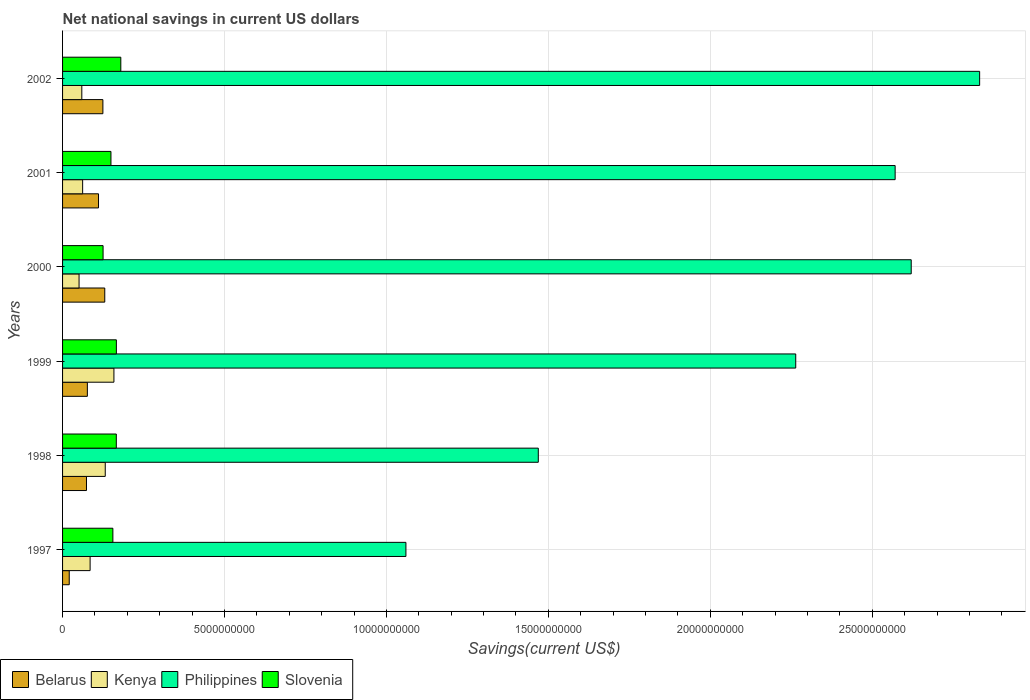Are the number of bars per tick equal to the number of legend labels?
Provide a succinct answer. Yes. How many bars are there on the 4th tick from the top?
Provide a succinct answer. 4. How many bars are there on the 5th tick from the bottom?
Keep it short and to the point. 4. What is the label of the 2nd group of bars from the top?
Your answer should be compact. 2001. What is the net national savings in Kenya in 1997?
Your answer should be compact. 8.50e+08. Across all years, what is the maximum net national savings in Belarus?
Provide a short and direct response. 1.30e+09. Across all years, what is the minimum net national savings in Belarus?
Your answer should be compact. 2.06e+08. In which year was the net national savings in Philippines minimum?
Your answer should be compact. 1997. What is the total net national savings in Philippines in the graph?
Give a very brief answer. 1.28e+11. What is the difference between the net national savings in Slovenia in 1999 and that in 2002?
Provide a succinct answer. -1.37e+08. What is the difference between the net national savings in Kenya in 1998 and the net national savings in Philippines in 2001?
Offer a terse response. -2.44e+1. What is the average net national savings in Slovenia per year?
Offer a terse response. 1.57e+09. In the year 1998, what is the difference between the net national savings in Slovenia and net national savings in Kenya?
Ensure brevity in your answer.  3.42e+08. What is the ratio of the net national savings in Kenya in 1997 to that in 2000?
Keep it short and to the point. 1.67. Is the net national savings in Kenya in 1997 less than that in 2000?
Offer a terse response. No. Is the difference between the net national savings in Slovenia in 1998 and 2000 greater than the difference between the net national savings in Kenya in 1998 and 2000?
Provide a succinct answer. No. What is the difference between the highest and the second highest net national savings in Slovenia?
Your answer should be compact. 1.37e+08. What is the difference between the highest and the lowest net national savings in Philippines?
Your answer should be compact. 1.77e+1. What does the 1st bar from the top in 1998 represents?
Keep it short and to the point. Slovenia. What does the 2nd bar from the bottom in 2002 represents?
Make the answer very short. Kenya. Is it the case that in every year, the sum of the net national savings in Philippines and net national savings in Kenya is greater than the net national savings in Belarus?
Ensure brevity in your answer.  Yes. Are all the bars in the graph horizontal?
Your answer should be compact. Yes. Are the values on the major ticks of X-axis written in scientific E-notation?
Your answer should be very brief. No. Does the graph contain any zero values?
Offer a very short reply. No. Does the graph contain grids?
Provide a short and direct response. Yes. What is the title of the graph?
Ensure brevity in your answer.  Net national savings in current US dollars. What is the label or title of the X-axis?
Make the answer very short. Savings(current US$). What is the Savings(current US$) in Belarus in 1997?
Offer a terse response. 2.06e+08. What is the Savings(current US$) in Kenya in 1997?
Offer a very short reply. 8.50e+08. What is the Savings(current US$) in Philippines in 1997?
Give a very brief answer. 1.06e+1. What is the Savings(current US$) in Slovenia in 1997?
Make the answer very short. 1.55e+09. What is the Savings(current US$) in Belarus in 1998?
Keep it short and to the point. 7.38e+08. What is the Savings(current US$) of Kenya in 1998?
Provide a succinct answer. 1.32e+09. What is the Savings(current US$) in Philippines in 1998?
Your response must be concise. 1.47e+1. What is the Savings(current US$) in Slovenia in 1998?
Offer a very short reply. 1.66e+09. What is the Savings(current US$) of Belarus in 1999?
Ensure brevity in your answer.  7.66e+08. What is the Savings(current US$) in Kenya in 1999?
Offer a terse response. 1.59e+09. What is the Savings(current US$) of Philippines in 1999?
Your answer should be compact. 2.26e+1. What is the Savings(current US$) in Slovenia in 1999?
Your response must be concise. 1.66e+09. What is the Savings(current US$) in Belarus in 2000?
Provide a succinct answer. 1.30e+09. What is the Savings(current US$) in Kenya in 2000?
Ensure brevity in your answer.  5.09e+08. What is the Savings(current US$) of Philippines in 2000?
Your response must be concise. 2.62e+1. What is the Savings(current US$) of Slovenia in 2000?
Ensure brevity in your answer.  1.25e+09. What is the Savings(current US$) in Belarus in 2001?
Ensure brevity in your answer.  1.11e+09. What is the Savings(current US$) in Kenya in 2001?
Offer a very short reply. 6.20e+08. What is the Savings(current US$) of Philippines in 2001?
Your response must be concise. 2.57e+1. What is the Savings(current US$) in Slovenia in 2001?
Make the answer very short. 1.49e+09. What is the Savings(current US$) of Belarus in 2002?
Provide a short and direct response. 1.25e+09. What is the Savings(current US$) in Kenya in 2002?
Offer a terse response. 5.94e+08. What is the Savings(current US$) in Philippines in 2002?
Give a very brief answer. 2.83e+1. What is the Savings(current US$) in Slovenia in 2002?
Provide a succinct answer. 1.80e+09. Across all years, what is the maximum Savings(current US$) in Belarus?
Make the answer very short. 1.30e+09. Across all years, what is the maximum Savings(current US$) of Kenya?
Your answer should be very brief. 1.59e+09. Across all years, what is the maximum Savings(current US$) of Philippines?
Ensure brevity in your answer.  2.83e+1. Across all years, what is the maximum Savings(current US$) of Slovenia?
Your response must be concise. 1.80e+09. Across all years, what is the minimum Savings(current US$) of Belarus?
Your response must be concise. 2.06e+08. Across all years, what is the minimum Savings(current US$) in Kenya?
Give a very brief answer. 5.09e+08. Across all years, what is the minimum Savings(current US$) in Philippines?
Ensure brevity in your answer.  1.06e+1. Across all years, what is the minimum Savings(current US$) of Slovenia?
Make the answer very short. 1.25e+09. What is the total Savings(current US$) in Belarus in the graph?
Offer a terse response. 5.37e+09. What is the total Savings(current US$) of Kenya in the graph?
Make the answer very short. 5.48e+09. What is the total Savings(current US$) of Philippines in the graph?
Offer a very short reply. 1.28e+11. What is the total Savings(current US$) of Slovenia in the graph?
Keep it short and to the point. 9.42e+09. What is the difference between the Savings(current US$) in Belarus in 1997 and that in 1998?
Provide a succinct answer. -5.33e+08. What is the difference between the Savings(current US$) in Kenya in 1997 and that in 1998?
Keep it short and to the point. -4.67e+08. What is the difference between the Savings(current US$) in Philippines in 1997 and that in 1998?
Your answer should be compact. -4.09e+09. What is the difference between the Savings(current US$) of Slovenia in 1997 and that in 1998?
Your response must be concise. -1.06e+08. What is the difference between the Savings(current US$) of Belarus in 1997 and that in 1999?
Your answer should be very brief. -5.60e+08. What is the difference between the Savings(current US$) in Kenya in 1997 and that in 1999?
Keep it short and to the point. -7.35e+08. What is the difference between the Savings(current US$) in Philippines in 1997 and that in 1999?
Give a very brief answer. -1.20e+1. What is the difference between the Savings(current US$) of Slovenia in 1997 and that in 1999?
Give a very brief answer. -1.08e+08. What is the difference between the Savings(current US$) in Belarus in 1997 and that in 2000?
Give a very brief answer. -1.10e+09. What is the difference between the Savings(current US$) of Kenya in 1997 and that in 2000?
Give a very brief answer. 3.41e+08. What is the difference between the Savings(current US$) in Philippines in 1997 and that in 2000?
Offer a very short reply. -1.56e+1. What is the difference between the Savings(current US$) of Slovenia in 1997 and that in 2000?
Give a very brief answer. 3.03e+08. What is the difference between the Savings(current US$) in Belarus in 1997 and that in 2001?
Your answer should be compact. -9.04e+08. What is the difference between the Savings(current US$) in Kenya in 1997 and that in 2001?
Provide a succinct answer. 2.31e+08. What is the difference between the Savings(current US$) of Philippines in 1997 and that in 2001?
Your answer should be very brief. -1.51e+1. What is the difference between the Savings(current US$) in Slovenia in 1997 and that in 2001?
Make the answer very short. 5.96e+07. What is the difference between the Savings(current US$) of Belarus in 1997 and that in 2002?
Your answer should be compact. -1.04e+09. What is the difference between the Savings(current US$) in Kenya in 1997 and that in 2002?
Keep it short and to the point. 2.56e+08. What is the difference between the Savings(current US$) in Philippines in 1997 and that in 2002?
Give a very brief answer. -1.77e+1. What is the difference between the Savings(current US$) in Slovenia in 1997 and that in 2002?
Make the answer very short. -2.45e+08. What is the difference between the Savings(current US$) in Belarus in 1998 and that in 1999?
Provide a short and direct response. -2.71e+07. What is the difference between the Savings(current US$) in Kenya in 1998 and that in 1999?
Offer a very short reply. -2.68e+08. What is the difference between the Savings(current US$) in Philippines in 1998 and that in 1999?
Make the answer very short. -7.95e+09. What is the difference between the Savings(current US$) of Slovenia in 1998 and that in 1999?
Provide a succinct answer. -2.00e+06. What is the difference between the Savings(current US$) of Belarus in 1998 and that in 2000?
Provide a succinct answer. -5.65e+08. What is the difference between the Savings(current US$) of Kenya in 1998 and that in 2000?
Offer a terse response. 8.08e+08. What is the difference between the Savings(current US$) of Philippines in 1998 and that in 2000?
Keep it short and to the point. -1.15e+1. What is the difference between the Savings(current US$) of Slovenia in 1998 and that in 2000?
Offer a terse response. 4.09e+08. What is the difference between the Savings(current US$) in Belarus in 1998 and that in 2001?
Your answer should be compact. -3.72e+08. What is the difference between the Savings(current US$) in Kenya in 1998 and that in 2001?
Ensure brevity in your answer.  6.98e+08. What is the difference between the Savings(current US$) of Philippines in 1998 and that in 2001?
Keep it short and to the point. -1.10e+1. What is the difference between the Savings(current US$) in Slovenia in 1998 and that in 2001?
Offer a very short reply. 1.66e+08. What is the difference between the Savings(current US$) in Belarus in 1998 and that in 2002?
Provide a succinct answer. -5.07e+08. What is the difference between the Savings(current US$) in Kenya in 1998 and that in 2002?
Your answer should be compact. 7.23e+08. What is the difference between the Savings(current US$) of Philippines in 1998 and that in 2002?
Give a very brief answer. -1.36e+1. What is the difference between the Savings(current US$) of Slovenia in 1998 and that in 2002?
Provide a succinct answer. -1.39e+08. What is the difference between the Savings(current US$) of Belarus in 1999 and that in 2000?
Your answer should be compact. -5.37e+08. What is the difference between the Savings(current US$) in Kenya in 1999 and that in 2000?
Provide a succinct answer. 1.08e+09. What is the difference between the Savings(current US$) of Philippines in 1999 and that in 2000?
Your answer should be compact. -3.57e+09. What is the difference between the Savings(current US$) in Slovenia in 1999 and that in 2000?
Your response must be concise. 4.11e+08. What is the difference between the Savings(current US$) of Belarus in 1999 and that in 2001?
Provide a succinct answer. -3.45e+08. What is the difference between the Savings(current US$) in Kenya in 1999 and that in 2001?
Your answer should be very brief. 9.66e+08. What is the difference between the Savings(current US$) of Philippines in 1999 and that in 2001?
Give a very brief answer. -3.07e+09. What is the difference between the Savings(current US$) in Slovenia in 1999 and that in 2001?
Provide a short and direct response. 1.68e+08. What is the difference between the Savings(current US$) in Belarus in 1999 and that in 2002?
Make the answer very short. -4.80e+08. What is the difference between the Savings(current US$) of Kenya in 1999 and that in 2002?
Your answer should be compact. 9.91e+08. What is the difference between the Savings(current US$) of Philippines in 1999 and that in 2002?
Ensure brevity in your answer.  -5.68e+09. What is the difference between the Savings(current US$) in Slovenia in 1999 and that in 2002?
Provide a short and direct response. -1.37e+08. What is the difference between the Savings(current US$) in Belarus in 2000 and that in 2001?
Your answer should be compact. 1.93e+08. What is the difference between the Savings(current US$) of Kenya in 2000 and that in 2001?
Give a very brief answer. -1.11e+08. What is the difference between the Savings(current US$) of Philippines in 2000 and that in 2001?
Offer a terse response. 4.96e+08. What is the difference between the Savings(current US$) in Slovenia in 2000 and that in 2001?
Your response must be concise. -2.43e+08. What is the difference between the Savings(current US$) of Belarus in 2000 and that in 2002?
Offer a very short reply. 5.77e+07. What is the difference between the Savings(current US$) of Kenya in 2000 and that in 2002?
Offer a very short reply. -8.50e+07. What is the difference between the Savings(current US$) of Philippines in 2000 and that in 2002?
Offer a very short reply. -2.11e+09. What is the difference between the Savings(current US$) in Slovenia in 2000 and that in 2002?
Make the answer very short. -5.47e+08. What is the difference between the Savings(current US$) in Belarus in 2001 and that in 2002?
Ensure brevity in your answer.  -1.35e+08. What is the difference between the Savings(current US$) of Kenya in 2001 and that in 2002?
Ensure brevity in your answer.  2.55e+07. What is the difference between the Savings(current US$) in Philippines in 2001 and that in 2002?
Your answer should be very brief. -2.61e+09. What is the difference between the Savings(current US$) in Slovenia in 2001 and that in 2002?
Offer a terse response. -3.04e+08. What is the difference between the Savings(current US$) in Belarus in 1997 and the Savings(current US$) in Kenya in 1998?
Make the answer very short. -1.11e+09. What is the difference between the Savings(current US$) of Belarus in 1997 and the Savings(current US$) of Philippines in 1998?
Give a very brief answer. -1.45e+1. What is the difference between the Savings(current US$) of Belarus in 1997 and the Savings(current US$) of Slovenia in 1998?
Ensure brevity in your answer.  -1.45e+09. What is the difference between the Savings(current US$) in Kenya in 1997 and the Savings(current US$) in Philippines in 1998?
Offer a very short reply. -1.38e+1. What is the difference between the Savings(current US$) of Kenya in 1997 and the Savings(current US$) of Slovenia in 1998?
Offer a very short reply. -8.09e+08. What is the difference between the Savings(current US$) in Philippines in 1997 and the Savings(current US$) in Slovenia in 1998?
Your response must be concise. 8.94e+09. What is the difference between the Savings(current US$) of Belarus in 1997 and the Savings(current US$) of Kenya in 1999?
Your answer should be very brief. -1.38e+09. What is the difference between the Savings(current US$) of Belarus in 1997 and the Savings(current US$) of Philippines in 1999?
Offer a terse response. -2.24e+1. What is the difference between the Savings(current US$) of Belarus in 1997 and the Savings(current US$) of Slovenia in 1999?
Your answer should be compact. -1.46e+09. What is the difference between the Savings(current US$) of Kenya in 1997 and the Savings(current US$) of Philippines in 1999?
Provide a succinct answer. -2.18e+1. What is the difference between the Savings(current US$) in Kenya in 1997 and the Savings(current US$) in Slovenia in 1999?
Provide a succinct answer. -8.11e+08. What is the difference between the Savings(current US$) of Philippines in 1997 and the Savings(current US$) of Slovenia in 1999?
Make the answer very short. 8.94e+09. What is the difference between the Savings(current US$) in Belarus in 1997 and the Savings(current US$) in Kenya in 2000?
Provide a succinct answer. -3.03e+08. What is the difference between the Savings(current US$) of Belarus in 1997 and the Savings(current US$) of Philippines in 2000?
Your answer should be compact. -2.60e+1. What is the difference between the Savings(current US$) of Belarus in 1997 and the Savings(current US$) of Slovenia in 2000?
Ensure brevity in your answer.  -1.04e+09. What is the difference between the Savings(current US$) of Kenya in 1997 and the Savings(current US$) of Philippines in 2000?
Your answer should be compact. -2.54e+1. What is the difference between the Savings(current US$) of Kenya in 1997 and the Savings(current US$) of Slovenia in 2000?
Offer a terse response. -4.00e+08. What is the difference between the Savings(current US$) in Philippines in 1997 and the Savings(current US$) in Slovenia in 2000?
Your answer should be compact. 9.35e+09. What is the difference between the Savings(current US$) in Belarus in 1997 and the Savings(current US$) in Kenya in 2001?
Your answer should be very brief. -4.14e+08. What is the difference between the Savings(current US$) in Belarus in 1997 and the Savings(current US$) in Philippines in 2001?
Provide a short and direct response. -2.55e+1. What is the difference between the Savings(current US$) of Belarus in 1997 and the Savings(current US$) of Slovenia in 2001?
Your answer should be very brief. -1.29e+09. What is the difference between the Savings(current US$) in Kenya in 1997 and the Savings(current US$) in Philippines in 2001?
Give a very brief answer. -2.49e+1. What is the difference between the Savings(current US$) in Kenya in 1997 and the Savings(current US$) in Slovenia in 2001?
Your response must be concise. -6.43e+08. What is the difference between the Savings(current US$) in Philippines in 1997 and the Savings(current US$) in Slovenia in 2001?
Make the answer very short. 9.11e+09. What is the difference between the Savings(current US$) in Belarus in 1997 and the Savings(current US$) in Kenya in 2002?
Your response must be concise. -3.88e+08. What is the difference between the Savings(current US$) of Belarus in 1997 and the Savings(current US$) of Philippines in 2002?
Provide a short and direct response. -2.81e+1. What is the difference between the Savings(current US$) in Belarus in 1997 and the Savings(current US$) in Slovenia in 2002?
Provide a short and direct response. -1.59e+09. What is the difference between the Savings(current US$) in Kenya in 1997 and the Savings(current US$) in Philippines in 2002?
Provide a succinct answer. -2.75e+1. What is the difference between the Savings(current US$) of Kenya in 1997 and the Savings(current US$) of Slovenia in 2002?
Offer a very short reply. -9.48e+08. What is the difference between the Savings(current US$) in Philippines in 1997 and the Savings(current US$) in Slovenia in 2002?
Your response must be concise. 8.80e+09. What is the difference between the Savings(current US$) of Belarus in 1998 and the Savings(current US$) of Kenya in 1999?
Provide a succinct answer. -8.47e+08. What is the difference between the Savings(current US$) of Belarus in 1998 and the Savings(current US$) of Philippines in 1999?
Your answer should be very brief. -2.19e+1. What is the difference between the Savings(current US$) in Belarus in 1998 and the Savings(current US$) in Slovenia in 1999?
Offer a terse response. -9.23e+08. What is the difference between the Savings(current US$) in Kenya in 1998 and the Savings(current US$) in Philippines in 1999?
Ensure brevity in your answer.  -2.13e+1. What is the difference between the Savings(current US$) of Kenya in 1998 and the Savings(current US$) of Slovenia in 1999?
Ensure brevity in your answer.  -3.44e+08. What is the difference between the Savings(current US$) in Philippines in 1998 and the Savings(current US$) in Slovenia in 1999?
Offer a terse response. 1.30e+1. What is the difference between the Savings(current US$) in Belarus in 1998 and the Savings(current US$) in Kenya in 2000?
Your answer should be very brief. 2.29e+08. What is the difference between the Savings(current US$) of Belarus in 1998 and the Savings(current US$) of Philippines in 2000?
Ensure brevity in your answer.  -2.55e+1. What is the difference between the Savings(current US$) of Belarus in 1998 and the Savings(current US$) of Slovenia in 2000?
Make the answer very short. -5.12e+08. What is the difference between the Savings(current US$) in Kenya in 1998 and the Savings(current US$) in Philippines in 2000?
Provide a short and direct response. -2.49e+1. What is the difference between the Savings(current US$) in Kenya in 1998 and the Savings(current US$) in Slovenia in 2000?
Ensure brevity in your answer.  6.69e+07. What is the difference between the Savings(current US$) in Philippines in 1998 and the Savings(current US$) in Slovenia in 2000?
Offer a terse response. 1.34e+1. What is the difference between the Savings(current US$) in Belarus in 1998 and the Savings(current US$) in Kenya in 2001?
Offer a very short reply. 1.19e+08. What is the difference between the Savings(current US$) of Belarus in 1998 and the Savings(current US$) of Philippines in 2001?
Give a very brief answer. -2.50e+1. What is the difference between the Savings(current US$) in Belarus in 1998 and the Savings(current US$) in Slovenia in 2001?
Offer a terse response. -7.55e+08. What is the difference between the Savings(current US$) in Kenya in 1998 and the Savings(current US$) in Philippines in 2001?
Ensure brevity in your answer.  -2.44e+1. What is the difference between the Savings(current US$) in Kenya in 1998 and the Savings(current US$) in Slovenia in 2001?
Your response must be concise. -1.76e+08. What is the difference between the Savings(current US$) of Philippines in 1998 and the Savings(current US$) of Slovenia in 2001?
Provide a short and direct response. 1.32e+1. What is the difference between the Savings(current US$) in Belarus in 1998 and the Savings(current US$) in Kenya in 2002?
Your response must be concise. 1.44e+08. What is the difference between the Savings(current US$) of Belarus in 1998 and the Savings(current US$) of Philippines in 2002?
Your answer should be very brief. -2.76e+1. What is the difference between the Savings(current US$) of Belarus in 1998 and the Savings(current US$) of Slovenia in 2002?
Provide a succinct answer. -1.06e+09. What is the difference between the Savings(current US$) of Kenya in 1998 and the Savings(current US$) of Philippines in 2002?
Your answer should be compact. -2.70e+1. What is the difference between the Savings(current US$) of Kenya in 1998 and the Savings(current US$) of Slovenia in 2002?
Ensure brevity in your answer.  -4.81e+08. What is the difference between the Savings(current US$) of Philippines in 1998 and the Savings(current US$) of Slovenia in 2002?
Your response must be concise. 1.29e+1. What is the difference between the Savings(current US$) in Belarus in 1999 and the Savings(current US$) in Kenya in 2000?
Provide a succinct answer. 2.56e+08. What is the difference between the Savings(current US$) of Belarus in 1999 and the Savings(current US$) of Philippines in 2000?
Ensure brevity in your answer.  -2.54e+1. What is the difference between the Savings(current US$) in Belarus in 1999 and the Savings(current US$) in Slovenia in 2000?
Your response must be concise. -4.85e+08. What is the difference between the Savings(current US$) in Kenya in 1999 and the Savings(current US$) in Philippines in 2000?
Make the answer very short. -2.46e+1. What is the difference between the Savings(current US$) in Kenya in 1999 and the Savings(current US$) in Slovenia in 2000?
Provide a succinct answer. 3.35e+08. What is the difference between the Savings(current US$) of Philippines in 1999 and the Savings(current US$) of Slovenia in 2000?
Ensure brevity in your answer.  2.14e+1. What is the difference between the Savings(current US$) in Belarus in 1999 and the Savings(current US$) in Kenya in 2001?
Your answer should be very brief. 1.46e+08. What is the difference between the Savings(current US$) of Belarus in 1999 and the Savings(current US$) of Philippines in 2001?
Ensure brevity in your answer.  -2.49e+1. What is the difference between the Savings(current US$) of Belarus in 1999 and the Savings(current US$) of Slovenia in 2001?
Keep it short and to the point. -7.28e+08. What is the difference between the Savings(current US$) in Kenya in 1999 and the Savings(current US$) in Philippines in 2001?
Offer a very short reply. -2.41e+1. What is the difference between the Savings(current US$) of Kenya in 1999 and the Savings(current US$) of Slovenia in 2001?
Give a very brief answer. 9.20e+07. What is the difference between the Savings(current US$) in Philippines in 1999 and the Savings(current US$) in Slovenia in 2001?
Ensure brevity in your answer.  2.11e+1. What is the difference between the Savings(current US$) in Belarus in 1999 and the Savings(current US$) in Kenya in 2002?
Provide a succinct answer. 1.71e+08. What is the difference between the Savings(current US$) in Belarus in 1999 and the Savings(current US$) in Philippines in 2002?
Provide a succinct answer. -2.76e+1. What is the difference between the Savings(current US$) of Belarus in 1999 and the Savings(current US$) of Slovenia in 2002?
Keep it short and to the point. -1.03e+09. What is the difference between the Savings(current US$) of Kenya in 1999 and the Savings(current US$) of Philippines in 2002?
Keep it short and to the point. -2.67e+1. What is the difference between the Savings(current US$) in Kenya in 1999 and the Savings(current US$) in Slovenia in 2002?
Your answer should be compact. -2.12e+08. What is the difference between the Savings(current US$) in Philippines in 1999 and the Savings(current US$) in Slovenia in 2002?
Give a very brief answer. 2.08e+1. What is the difference between the Savings(current US$) in Belarus in 2000 and the Savings(current US$) in Kenya in 2001?
Your response must be concise. 6.83e+08. What is the difference between the Savings(current US$) in Belarus in 2000 and the Savings(current US$) in Philippines in 2001?
Keep it short and to the point. -2.44e+1. What is the difference between the Savings(current US$) in Belarus in 2000 and the Savings(current US$) in Slovenia in 2001?
Offer a very short reply. -1.91e+08. What is the difference between the Savings(current US$) in Kenya in 2000 and the Savings(current US$) in Philippines in 2001?
Give a very brief answer. -2.52e+1. What is the difference between the Savings(current US$) in Kenya in 2000 and the Savings(current US$) in Slovenia in 2001?
Make the answer very short. -9.84e+08. What is the difference between the Savings(current US$) in Philippines in 2000 and the Savings(current US$) in Slovenia in 2001?
Give a very brief answer. 2.47e+1. What is the difference between the Savings(current US$) in Belarus in 2000 and the Savings(current US$) in Kenya in 2002?
Ensure brevity in your answer.  7.09e+08. What is the difference between the Savings(current US$) in Belarus in 2000 and the Savings(current US$) in Philippines in 2002?
Ensure brevity in your answer.  -2.70e+1. What is the difference between the Savings(current US$) in Belarus in 2000 and the Savings(current US$) in Slovenia in 2002?
Provide a succinct answer. -4.95e+08. What is the difference between the Savings(current US$) of Kenya in 2000 and the Savings(current US$) of Philippines in 2002?
Provide a succinct answer. -2.78e+1. What is the difference between the Savings(current US$) in Kenya in 2000 and the Savings(current US$) in Slovenia in 2002?
Provide a short and direct response. -1.29e+09. What is the difference between the Savings(current US$) in Philippines in 2000 and the Savings(current US$) in Slovenia in 2002?
Give a very brief answer. 2.44e+1. What is the difference between the Savings(current US$) in Belarus in 2001 and the Savings(current US$) in Kenya in 2002?
Provide a succinct answer. 5.16e+08. What is the difference between the Savings(current US$) in Belarus in 2001 and the Savings(current US$) in Philippines in 2002?
Provide a short and direct response. -2.72e+1. What is the difference between the Savings(current US$) in Belarus in 2001 and the Savings(current US$) in Slovenia in 2002?
Keep it short and to the point. -6.88e+08. What is the difference between the Savings(current US$) of Kenya in 2001 and the Savings(current US$) of Philippines in 2002?
Keep it short and to the point. -2.77e+1. What is the difference between the Savings(current US$) in Kenya in 2001 and the Savings(current US$) in Slovenia in 2002?
Provide a short and direct response. -1.18e+09. What is the difference between the Savings(current US$) of Philippines in 2001 and the Savings(current US$) of Slovenia in 2002?
Your response must be concise. 2.39e+1. What is the average Savings(current US$) in Belarus per year?
Offer a very short reply. 8.95e+08. What is the average Savings(current US$) of Kenya per year?
Your answer should be very brief. 9.13e+08. What is the average Savings(current US$) of Philippines per year?
Offer a very short reply. 2.14e+1. What is the average Savings(current US$) of Slovenia per year?
Make the answer very short. 1.57e+09. In the year 1997, what is the difference between the Savings(current US$) in Belarus and Savings(current US$) in Kenya?
Provide a short and direct response. -6.44e+08. In the year 1997, what is the difference between the Savings(current US$) in Belarus and Savings(current US$) in Philippines?
Provide a short and direct response. -1.04e+1. In the year 1997, what is the difference between the Savings(current US$) of Belarus and Savings(current US$) of Slovenia?
Keep it short and to the point. -1.35e+09. In the year 1997, what is the difference between the Savings(current US$) of Kenya and Savings(current US$) of Philippines?
Provide a succinct answer. -9.75e+09. In the year 1997, what is the difference between the Savings(current US$) of Kenya and Savings(current US$) of Slovenia?
Keep it short and to the point. -7.03e+08. In the year 1997, what is the difference between the Savings(current US$) of Philippines and Savings(current US$) of Slovenia?
Keep it short and to the point. 9.05e+09. In the year 1998, what is the difference between the Savings(current US$) of Belarus and Savings(current US$) of Kenya?
Ensure brevity in your answer.  -5.79e+08. In the year 1998, what is the difference between the Savings(current US$) in Belarus and Savings(current US$) in Philippines?
Provide a succinct answer. -1.40e+1. In the year 1998, what is the difference between the Savings(current US$) of Belarus and Savings(current US$) of Slovenia?
Provide a succinct answer. -9.21e+08. In the year 1998, what is the difference between the Savings(current US$) in Kenya and Savings(current US$) in Philippines?
Your answer should be very brief. -1.34e+1. In the year 1998, what is the difference between the Savings(current US$) in Kenya and Savings(current US$) in Slovenia?
Offer a very short reply. -3.42e+08. In the year 1998, what is the difference between the Savings(current US$) in Philippines and Savings(current US$) in Slovenia?
Make the answer very short. 1.30e+1. In the year 1999, what is the difference between the Savings(current US$) in Belarus and Savings(current US$) in Kenya?
Your response must be concise. -8.20e+08. In the year 1999, what is the difference between the Savings(current US$) of Belarus and Savings(current US$) of Philippines?
Provide a succinct answer. -2.19e+1. In the year 1999, what is the difference between the Savings(current US$) in Belarus and Savings(current US$) in Slovenia?
Your answer should be very brief. -8.96e+08. In the year 1999, what is the difference between the Savings(current US$) of Kenya and Savings(current US$) of Philippines?
Give a very brief answer. -2.11e+1. In the year 1999, what is the difference between the Savings(current US$) of Kenya and Savings(current US$) of Slovenia?
Give a very brief answer. -7.56e+07. In the year 1999, what is the difference between the Savings(current US$) in Philippines and Savings(current US$) in Slovenia?
Your answer should be compact. 2.10e+1. In the year 2000, what is the difference between the Savings(current US$) of Belarus and Savings(current US$) of Kenya?
Give a very brief answer. 7.94e+08. In the year 2000, what is the difference between the Savings(current US$) in Belarus and Savings(current US$) in Philippines?
Your answer should be compact. -2.49e+1. In the year 2000, what is the difference between the Savings(current US$) of Belarus and Savings(current US$) of Slovenia?
Provide a short and direct response. 5.22e+07. In the year 2000, what is the difference between the Savings(current US$) of Kenya and Savings(current US$) of Philippines?
Your answer should be compact. -2.57e+1. In the year 2000, what is the difference between the Savings(current US$) in Kenya and Savings(current US$) in Slovenia?
Provide a short and direct response. -7.41e+08. In the year 2000, what is the difference between the Savings(current US$) of Philippines and Savings(current US$) of Slovenia?
Give a very brief answer. 2.50e+1. In the year 2001, what is the difference between the Savings(current US$) of Belarus and Savings(current US$) of Kenya?
Offer a terse response. 4.90e+08. In the year 2001, what is the difference between the Savings(current US$) of Belarus and Savings(current US$) of Philippines?
Provide a short and direct response. -2.46e+1. In the year 2001, what is the difference between the Savings(current US$) in Belarus and Savings(current US$) in Slovenia?
Your answer should be very brief. -3.84e+08. In the year 2001, what is the difference between the Savings(current US$) in Kenya and Savings(current US$) in Philippines?
Give a very brief answer. -2.51e+1. In the year 2001, what is the difference between the Savings(current US$) of Kenya and Savings(current US$) of Slovenia?
Keep it short and to the point. -8.74e+08. In the year 2001, what is the difference between the Savings(current US$) in Philippines and Savings(current US$) in Slovenia?
Ensure brevity in your answer.  2.42e+1. In the year 2002, what is the difference between the Savings(current US$) in Belarus and Savings(current US$) in Kenya?
Your answer should be very brief. 6.51e+08. In the year 2002, what is the difference between the Savings(current US$) in Belarus and Savings(current US$) in Philippines?
Offer a terse response. -2.71e+1. In the year 2002, what is the difference between the Savings(current US$) of Belarus and Savings(current US$) of Slovenia?
Keep it short and to the point. -5.53e+08. In the year 2002, what is the difference between the Savings(current US$) of Kenya and Savings(current US$) of Philippines?
Your answer should be very brief. -2.77e+1. In the year 2002, what is the difference between the Savings(current US$) in Kenya and Savings(current US$) in Slovenia?
Provide a succinct answer. -1.20e+09. In the year 2002, what is the difference between the Savings(current US$) of Philippines and Savings(current US$) of Slovenia?
Keep it short and to the point. 2.65e+1. What is the ratio of the Savings(current US$) in Belarus in 1997 to that in 1998?
Provide a succinct answer. 0.28. What is the ratio of the Savings(current US$) in Kenya in 1997 to that in 1998?
Keep it short and to the point. 0.65. What is the ratio of the Savings(current US$) of Philippines in 1997 to that in 1998?
Ensure brevity in your answer.  0.72. What is the ratio of the Savings(current US$) in Slovenia in 1997 to that in 1998?
Your answer should be very brief. 0.94. What is the ratio of the Savings(current US$) in Belarus in 1997 to that in 1999?
Provide a succinct answer. 0.27. What is the ratio of the Savings(current US$) of Kenya in 1997 to that in 1999?
Ensure brevity in your answer.  0.54. What is the ratio of the Savings(current US$) of Philippines in 1997 to that in 1999?
Offer a terse response. 0.47. What is the ratio of the Savings(current US$) of Slovenia in 1997 to that in 1999?
Offer a terse response. 0.94. What is the ratio of the Savings(current US$) of Belarus in 1997 to that in 2000?
Provide a succinct answer. 0.16. What is the ratio of the Savings(current US$) in Kenya in 1997 to that in 2000?
Provide a succinct answer. 1.67. What is the ratio of the Savings(current US$) in Philippines in 1997 to that in 2000?
Keep it short and to the point. 0.4. What is the ratio of the Savings(current US$) of Slovenia in 1997 to that in 2000?
Keep it short and to the point. 1.24. What is the ratio of the Savings(current US$) in Belarus in 1997 to that in 2001?
Offer a very short reply. 0.19. What is the ratio of the Savings(current US$) of Kenya in 1997 to that in 2001?
Make the answer very short. 1.37. What is the ratio of the Savings(current US$) in Philippines in 1997 to that in 2001?
Your answer should be very brief. 0.41. What is the ratio of the Savings(current US$) of Slovenia in 1997 to that in 2001?
Make the answer very short. 1.04. What is the ratio of the Savings(current US$) in Belarus in 1997 to that in 2002?
Offer a terse response. 0.17. What is the ratio of the Savings(current US$) of Kenya in 1997 to that in 2002?
Your response must be concise. 1.43. What is the ratio of the Savings(current US$) of Philippines in 1997 to that in 2002?
Keep it short and to the point. 0.37. What is the ratio of the Savings(current US$) of Slovenia in 1997 to that in 2002?
Your answer should be very brief. 0.86. What is the ratio of the Savings(current US$) of Belarus in 1998 to that in 1999?
Offer a very short reply. 0.96. What is the ratio of the Savings(current US$) of Kenya in 1998 to that in 1999?
Your response must be concise. 0.83. What is the ratio of the Savings(current US$) of Philippines in 1998 to that in 1999?
Your answer should be compact. 0.65. What is the ratio of the Savings(current US$) in Belarus in 1998 to that in 2000?
Your response must be concise. 0.57. What is the ratio of the Savings(current US$) of Kenya in 1998 to that in 2000?
Your response must be concise. 2.59. What is the ratio of the Savings(current US$) of Philippines in 1998 to that in 2000?
Your response must be concise. 0.56. What is the ratio of the Savings(current US$) in Slovenia in 1998 to that in 2000?
Keep it short and to the point. 1.33. What is the ratio of the Savings(current US$) of Belarus in 1998 to that in 2001?
Ensure brevity in your answer.  0.67. What is the ratio of the Savings(current US$) of Kenya in 1998 to that in 2001?
Offer a very short reply. 2.13. What is the ratio of the Savings(current US$) in Slovenia in 1998 to that in 2001?
Provide a succinct answer. 1.11. What is the ratio of the Savings(current US$) of Belarus in 1998 to that in 2002?
Your answer should be compact. 0.59. What is the ratio of the Savings(current US$) in Kenya in 1998 to that in 2002?
Give a very brief answer. 2.22. What is the ratio of the Savings(current US$) of Philippines in 1998 to that in 2002?
Your response must be concise. 0.52. What is the ratio of the Savings(current US$) of Slovenia in 1998 to that in 2002?
Keep it short and to the point. 0.92. What is the ratio of the Savings(current US$) of Belarus in 1999 to that in 2000?
Offer a very short reply. 0.59. What is the ratio of the Savings(current US$) of Kenya in 1999 to that in 2000?
Offer a terse response. 3.11. What is the ratio of the Savings(current US$) in Philippines in 1999 to that in 2000?
Your answer should be compact. 0.86. What is the ratio of the Savings(current US$) of Slovenia in 1999 to that in 2000?
Offer a very short reply. 1.33. What is the ratio of the Savings(current US$) in Belarus in 1999 to that in 2001?
Ensure brevity in your answer.  0.69. What is the ratio of the Savings(current US$) in Kenya in 1999 to that in 2001?
Offer a very short reply. 2.56. What is the ratio of the Savings(current US$) in Philippines in 1999 to that in 2001?
Your response must be concise. 0.88. What is the ratio of the Savings(current US$) in Slovenia in 1999 to that in 2001?
Your answer should be compact. 1.11. What is the ratio of the Savings(current US$) in Belarus in 1999 to that in 2002?
Make the answer very short. 0.61. What is the ratio of the Savings(current US$) in Kenya in 1999 to that in 2002?
Make the answer very short. 2.67. What is the ratio of the Savings(current US$) of Philippines in 1999 to that in 2002?
Keep it short and to the point. 0.8. What is the ratio of the Savings(current US$) of Slovenia in 1999 to that in 2002?
Your response must be concise. 0.92. What is the ratio of the Savings(current US$) of Belarus in 2000 to that in 2001?
Your answer should be very brief. 1.17. What is the ratio of the Savings(current US$) of Kenya in 2000 to that in 2001?
Keep it short and to the point. 0.82. What is the ratio of the Savings(current US$) in Philippines in 2000 to that in 2001?
Provide a succinct answer. 1.02. What is the ratio of the Savings(current US$) in Slovenia in 2000 to that in 2001?
Provide a short and direct response. 0.84. What is the ratio of the Savings(current US$) in Belarus in 2000 to that in 2002?
Make the answer very short. 1.05. What is the ratio of the Savings(current US$) of Kenya in 2000 to that in 2002?
Your answer should be very brief. 0.86. What is the ratio of the Savings(current US$) in Philippines in 2000 to that in 2002?
Offer a very short reply. 0.93. What is the ratio of the Savings(current US$) of Slovenia in 2000 to that in 2002?
Offer a terse response. 0.7. What is the ratio of the Savings(current US$) in Belarus in 2001 to that in 2002?
Make the answer very short. 0.89. What is the ratio of the Savings(current US$) of Kenya in 2001 to that in 2002?
Ensure brevity in your answer.  1.04. What is the ratio of the Savings(current US$) of Philippines in 2001 to that in 2002?
Provide a succinct answer. 0.91. What is the ratio of the Savings(current US$) of Slovenia in 2001 to that in 2002?
Give a very brief answer. 0.83. What is the difference between the highest and the second highest Savings(current US$) of Belarus?
Your response must be concise. 5.77e+07. What is the difference between the highest and the second highest Savings(current US$) in Kenya?
Offer a very short reply. 2.68e+08. What is the difference between the highest and the second highest Savings(current US$) of Philippines?
Your answer should be very brief. 2.11e+09. What is the difference between the highest and the second highest Savings(current US$) in Slovenia?
Your response must be concise. 1.37e+08. What is the difference between the highest and the lowest Savings(current US$) of Belarus?
Provide a short and direct response. 1.10e+09. What is the difference between the highest and the lowest Savings(current US$) in Kenya?
Give a very brief answer. 1.08e+09. What is the difference between the highest and the lowest Savings(current US$) of Philippines?
Provide a succinct answer. 1.77e+1. What is the difference between the highest and the lowest Savings(current US$) of Slovenia?
Provide a succinct answer. 5.47e+08. 